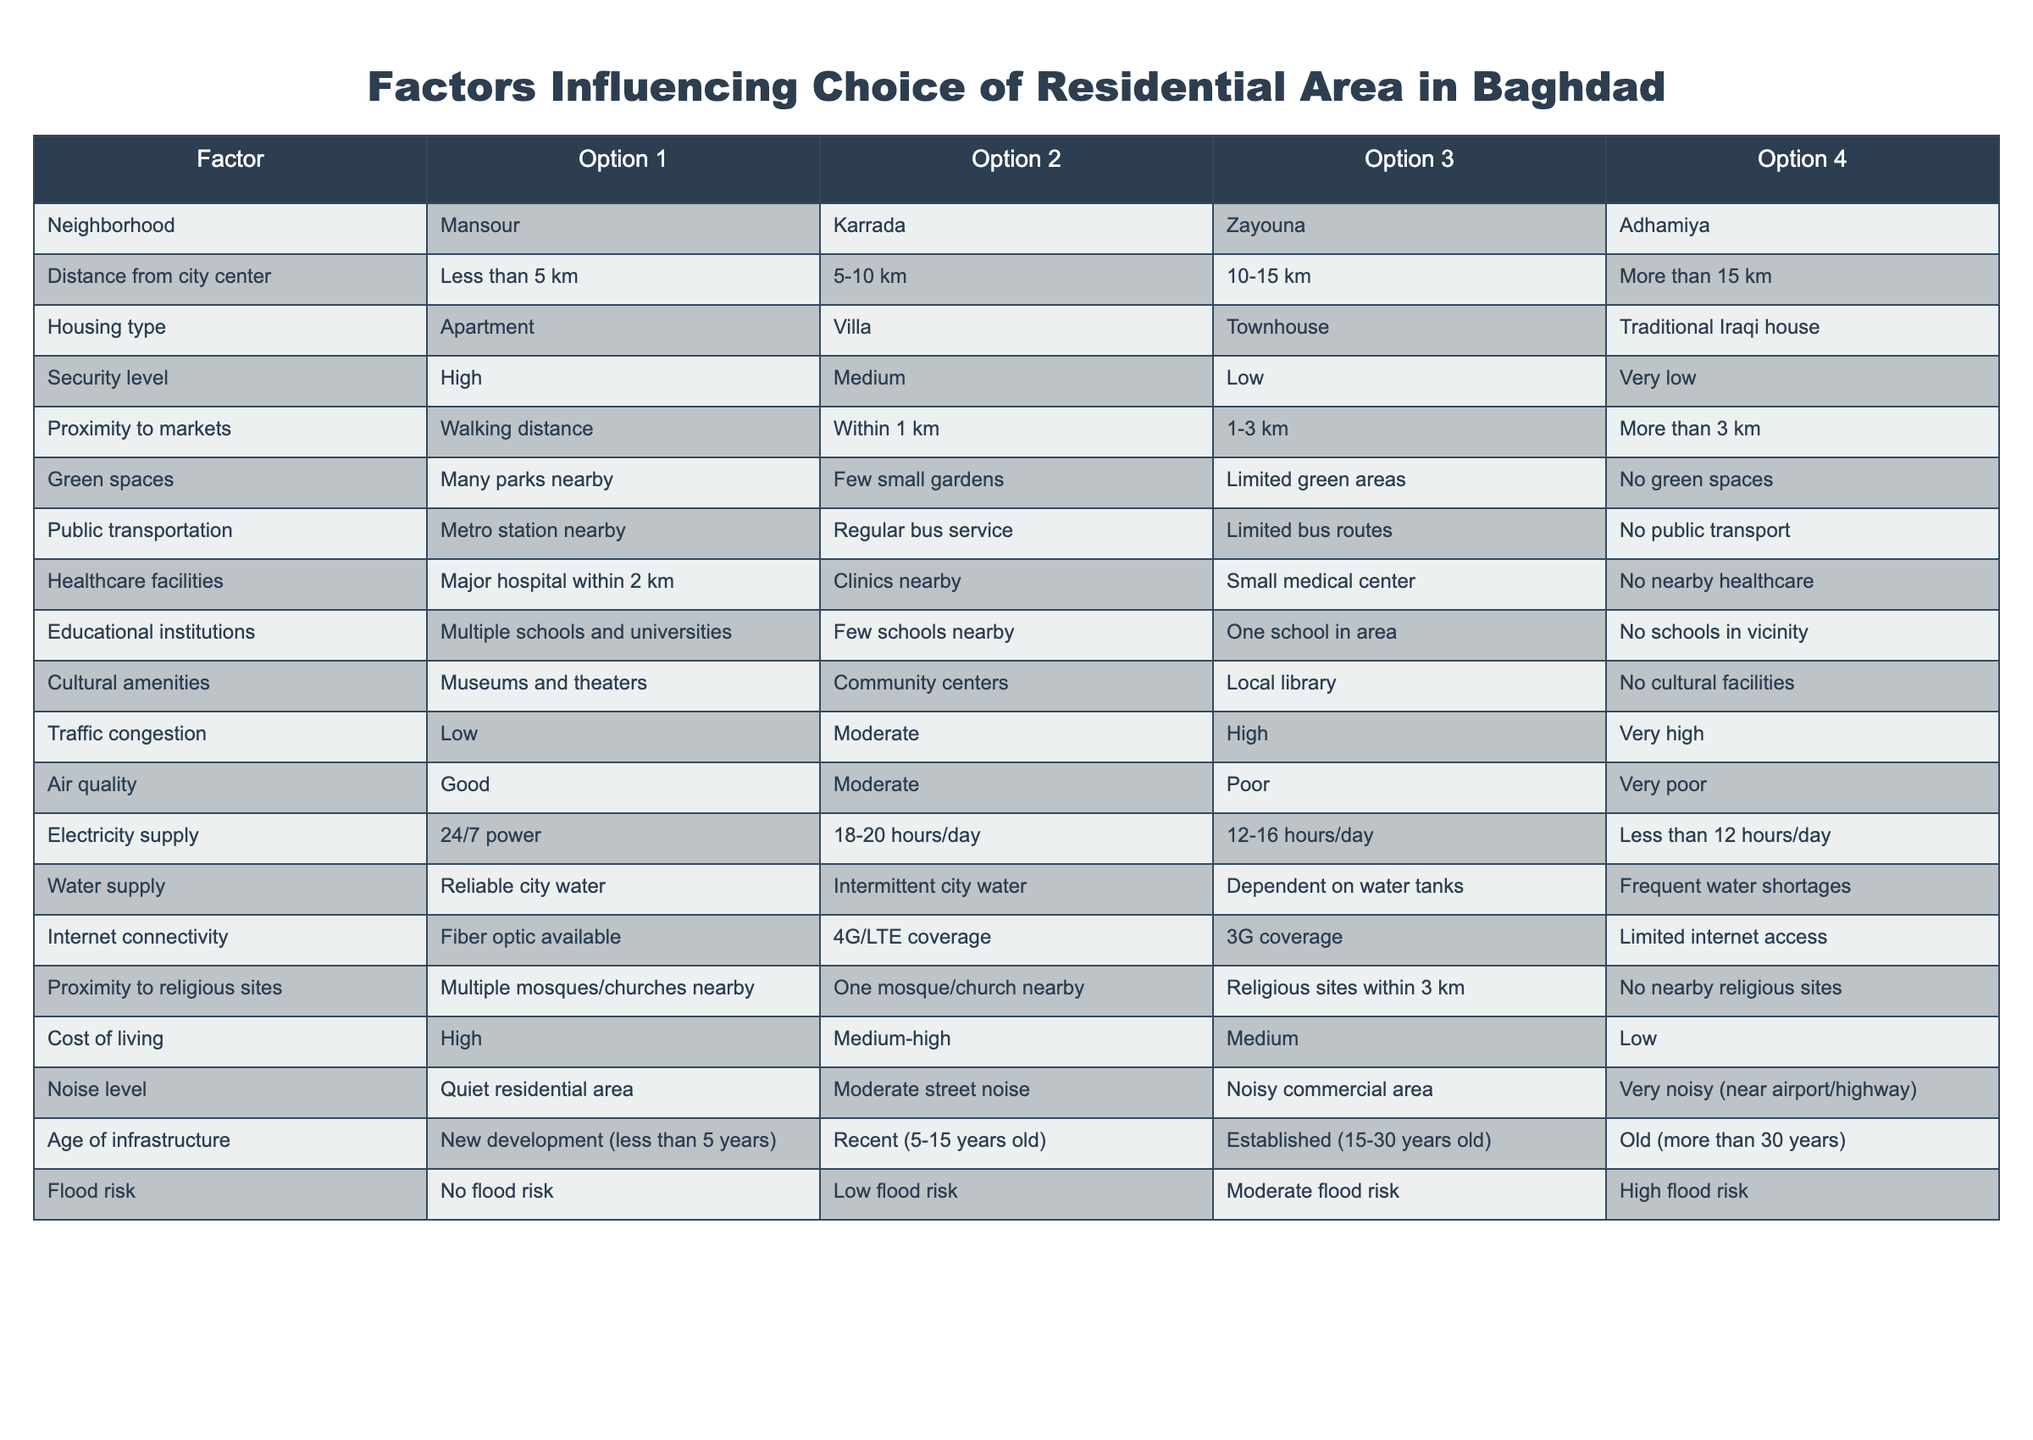What neighborhood offers the highest security level? The table indicates that Mansour has a high security level. By scanning the "Neighborhood" row for "High" in the "Security level" column, we see that it corresponds with Mansour.
Answer: Mansour What is the average distance from the city center of all options? The distances in kilometers are categorized as: Less than 5 km (assume average of 2.5 km), 5-10 km (average of 7.5 km), 10-15 km (average of 12.5 km), and More than 15 km (assume average of 17.5 km). The calculation is (2.5 + 7.5 + 12.5 + 17.5) / 4 = 10. The average distance is therefore 10 km.
Answer: 10 km Which housing type is associated with the highest electricity supply hours? The table states that 24/7 power corresponds to the "Apartment" option. By reviewing the "Electricity supply" row, we can observe that apartments have the highest supply available.
Answer: Apartment Is there public transportation available in Zayouna? According to the table, Zayouna shows "Limited bus routes" in the "Public transportation" section. Therefore, there is a form of transportation, albeit not extensive.
Answer: Yes What is the combination of traffic congestion and air quality in Karrada? From the table, Karrada has a "Moderate" traffic congestion level and "Good" air quality level. To find the combined condition, both attributes are assessed directly, indicating that Karrada has a moderate level of traffic with good air quality.
Answer: Moderate traffic, Good air quality What factor has the highest variability among the options presented? By analyzing the different categories, "Cost of living" spans from "High" to "Low," which suggests significant variability among financial expectations. This row showcases a clear range within residential choices.
Answer: Cost of living Does Adhamiya have reliable water supply? The table lists "No reliable city water" as an option for Adhamiya under "Water supply." It indicates that Adhamiya does not have a stable water supply.
Answer: No What are the common factors between the neighborhoods of Mansour and Adhamiya? By reviewing the two neighborhoods, we look at aspects like housing type, security level, and proximity to markets for comparison. Both options show viable housing types but reveal stark differences in security and market access levels. Thus, both neighborhoods have distinct characteristics.
Answer: Distinct characteristics 